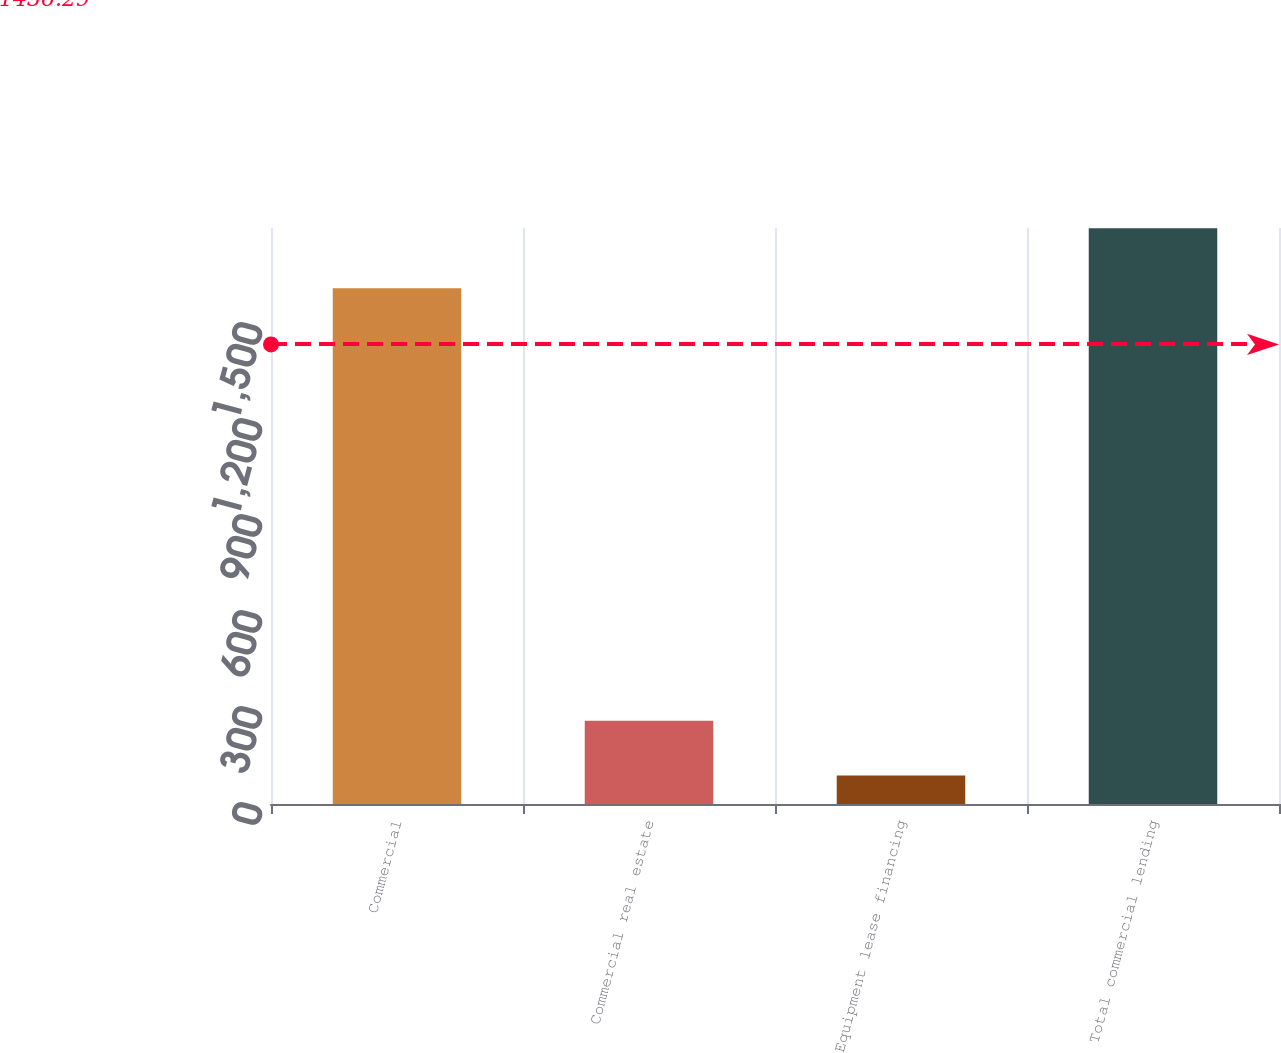Convert chart to OTSL. <chart><loc_0><loc_0><loc_500><loc_500><bar_chart><fcel>Commercial<fcel>Commercial real estate<fcel>Equipment lease financing<fcel>Total commercial lending<nl><fcel>1612<fcel>260<fcel>89<fcel>1799<nl></chart> 